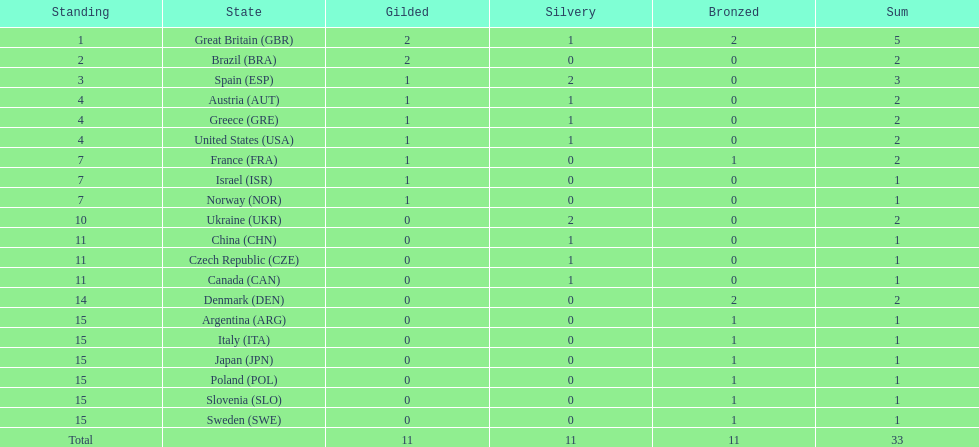What was the total number of medals won by united states? 2. 